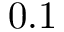<formula> <loc_0><loc_0><loc_500><loc_500>0 . 1</formula> 